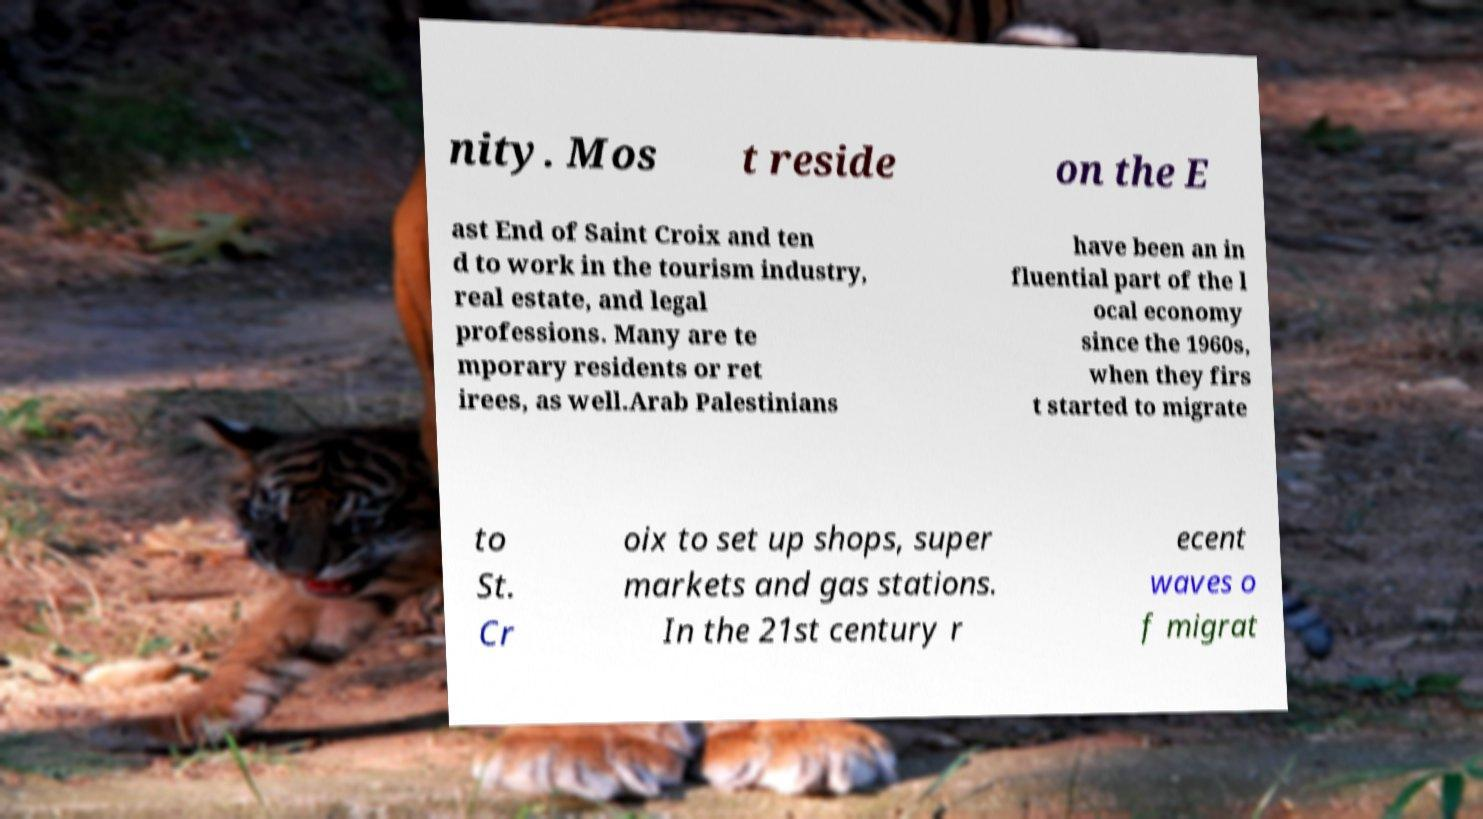Please identify and transcribe the text found in this image. nity. Mos t reside on the E ast End of Saint Croix and ten d to work in the tourism industry, real estate, and legal professions. Many are te mporary residents or ret irees, as well.Arab Palestinians have been an in fluential part of the l ocal economy since the 1960s, when they firs t started to migrate to St. Cr oix to set up shops, super markets and gas stations. In the 21st century r ecent waves o f migrat 